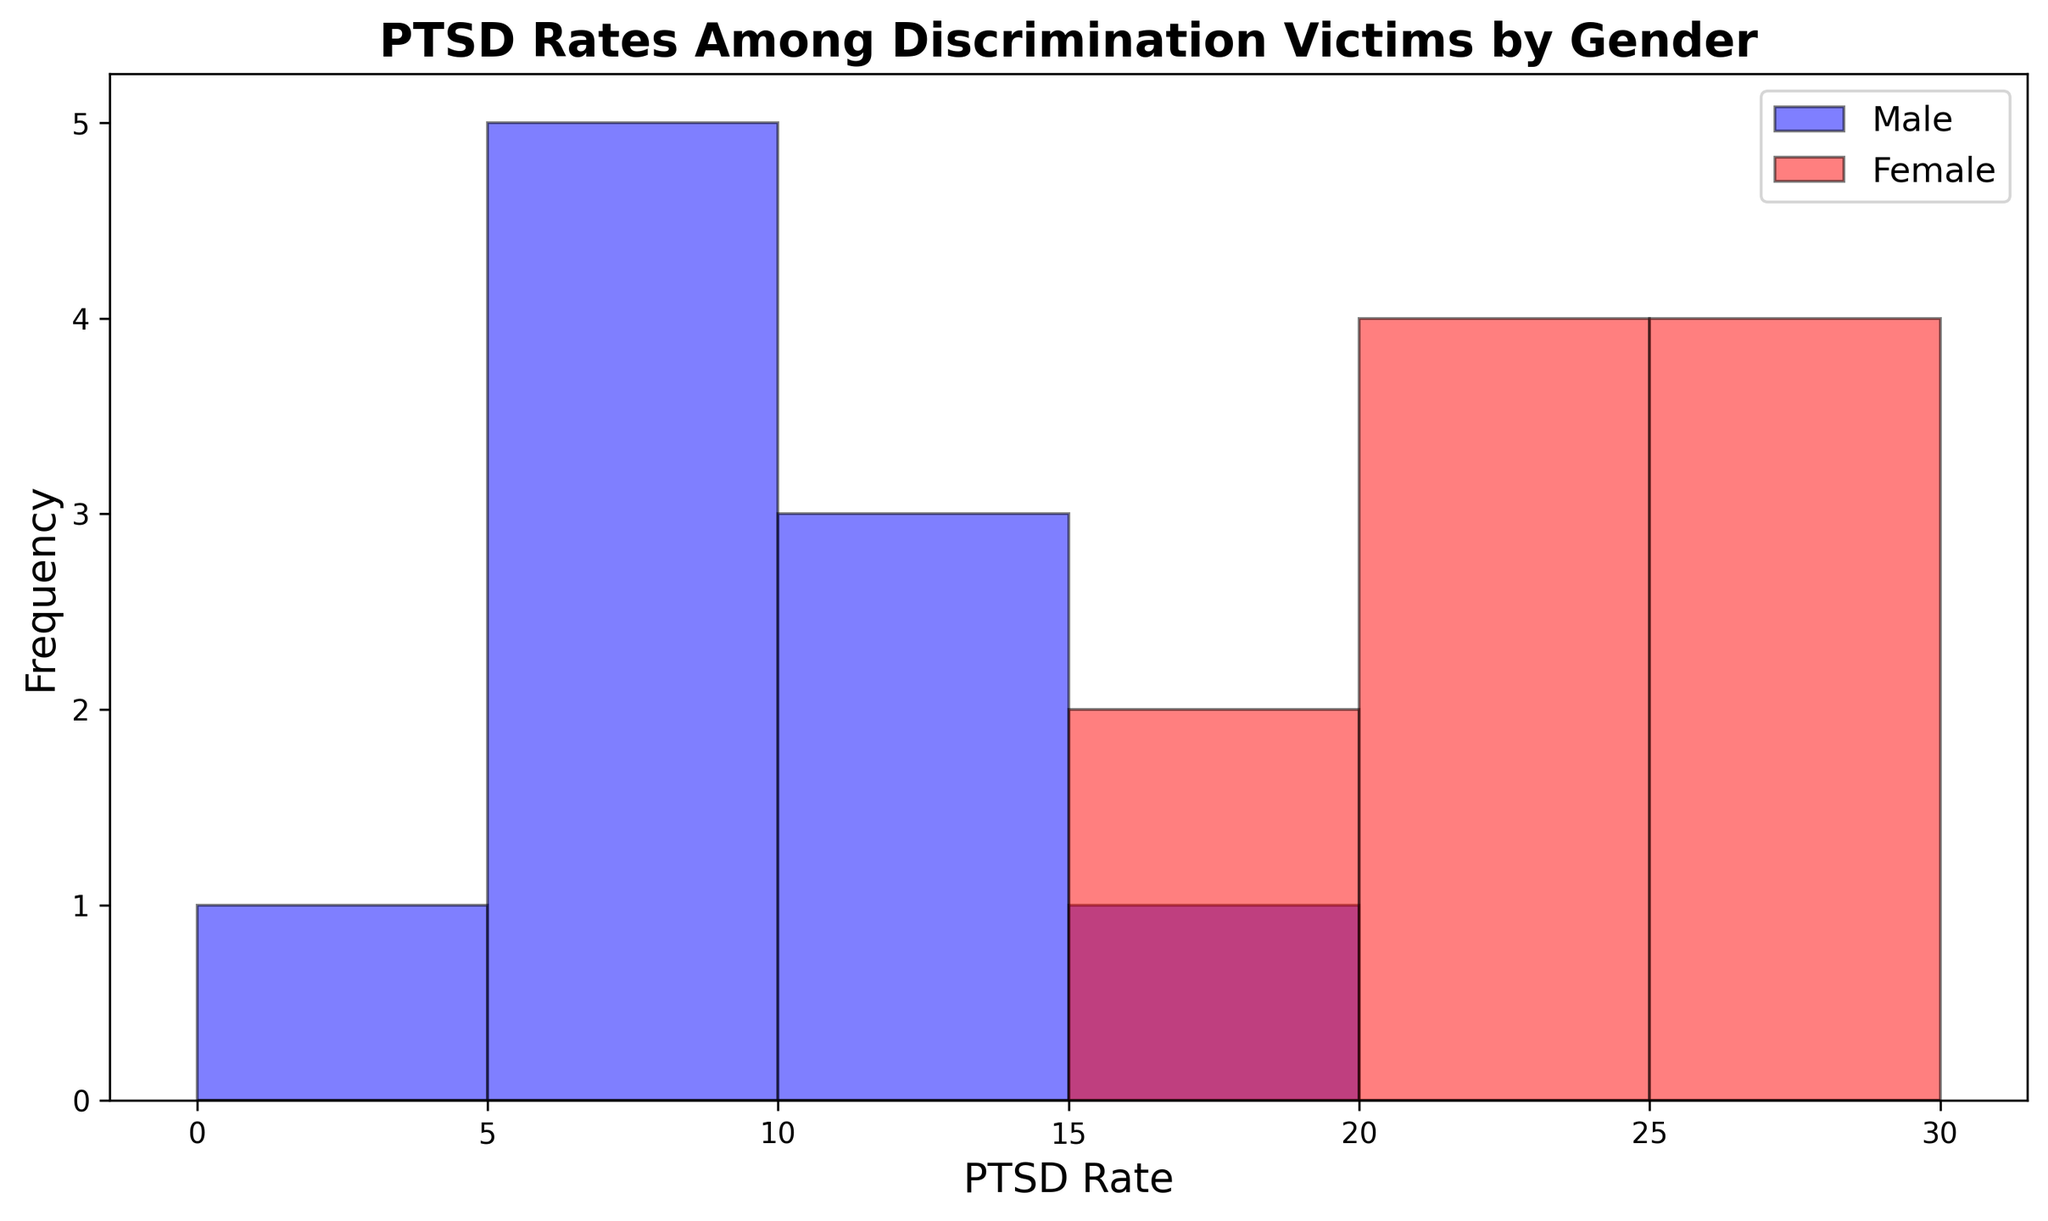How many bins are used in the histogram to represent the PTSD rates? To find the number of bins, count the intervals displayed on the x-axis from 0 to the maximum PTSD rate. The histogram uses bins of size 5, so they range from 0 (inclusive) to 35 (exclusive), making it seven bins.
Answer: 7 Which gender group shows a higher frequency of PTSD rates in the 20-25 bin? Compare the height of the bars for males and females within the 20-25 PTSD rate bin. The bar for the Female group is taller in this bin.
Answer: Female What is the frequency of the highest PTSD rate bin for females? Identify the frequency by looking at the tallest bar's position for females within the range of PTSD rates, which is the 30-35 bin for females.
Answer: 2 What is the average PTSD rate for males based on the visual information? Sum all the PTSD rates for males (10, 15, 5, 12, 8, 7, 6, 11, 9, 4) and divide by the number of samples (10). The sum is 87, so the average is 87/10.
Answer: 8.7 How does the most frequent PTSD rate range compare between males and females? Determine the most frequent PTSD rate range by looking for the highest bar for each gender. For males, it is the 10-15 bin, and for females, it is the 20-25 bin.
Answer: Males: 10-15, Females: 20-25 Which PTSD rate bins do both male and female groups have values for, and which does each gender group have uniquely? Identify the bins where both male and female bars are present. Both genders have values in 5-10, 10-15, 15-20, 20-25, and 25-30 bins. Unique bins are those where only one gender has values. Only females have values in the 30-35 bin.
Answer: Both: 5-30, Unique (Female): 30-35 What is the difference between the maximum PTSD rates observed for males and females? Compare the maximum PTSD rate for each gender: the highest rate for males is 15, and for females, it is 30. Subtract the male's max from the female's max.
Answer: 15 By how much does the female PTSD rate in the 15-20 bin exceed the male PTSD rate in the same bin? Determine the height of the histogram bars for males and females in the 15-20 bin. Females have a rate frequency of 2, and males have a rate frequency of 1 in this bin. The difference is 2 - 1.
Answer: 1 Which bin has the most considerable difference in the frequency of PTSD rates between genders? Compare the difference in height of corresponding bars among bins. The most significant difference is in the 30-35 bin (females) where males have no count.
Answer: 30-35 (Females) What percentage of the male samples fall into the 5-10 PTSD rate bin? Count the number of male samples in the 5-10 range (3) and divide by the total number of male samples (10). Multiply by 100 to get the percentage: \((3/10) * 100\).
Answer: 30% 